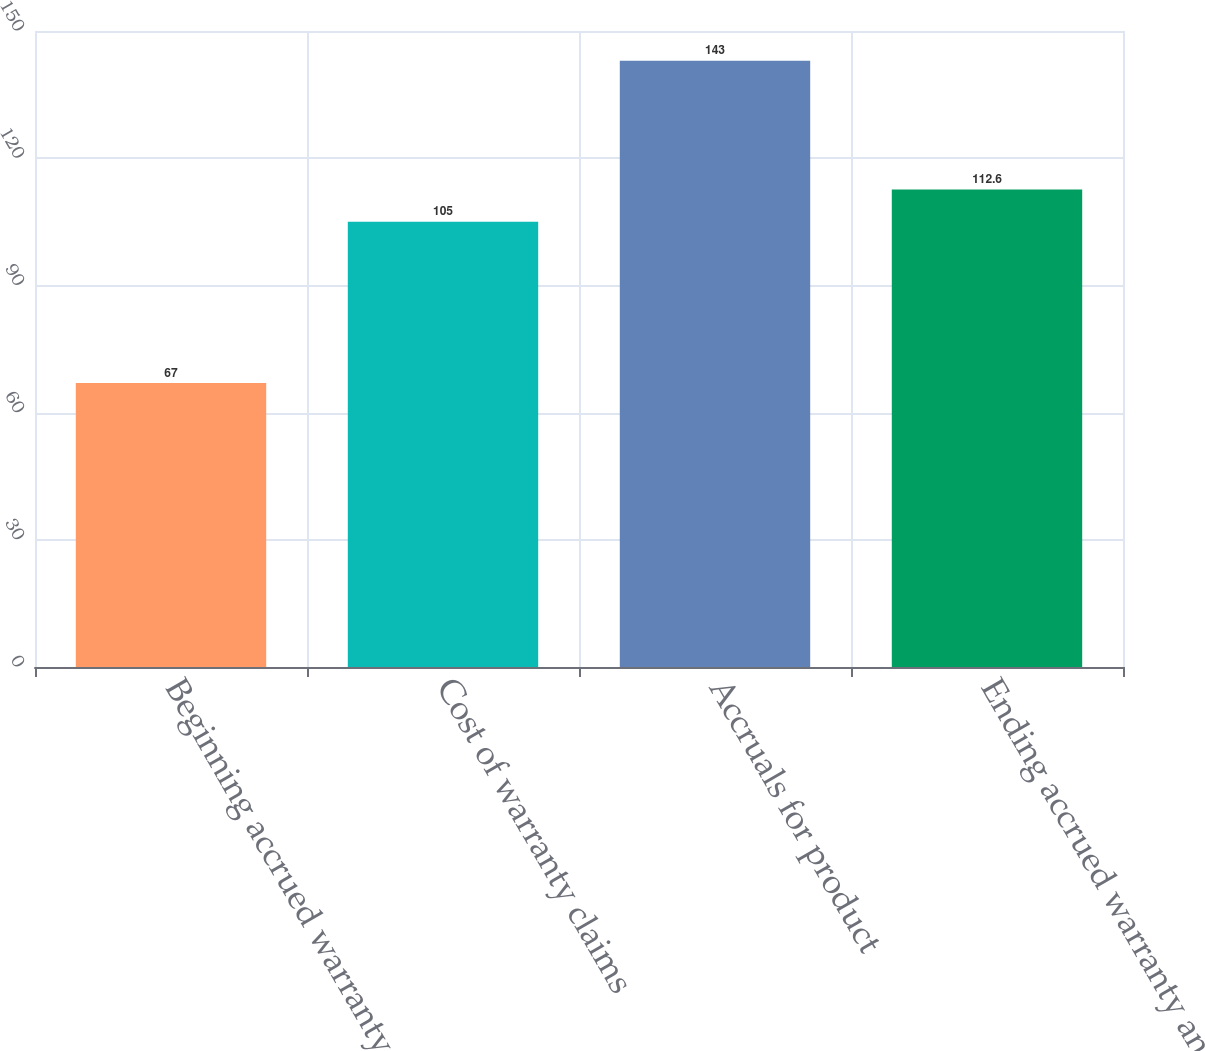Convert chart to OTSL. <chart><loc_0><loc_0><loc_500><loc_500><bar_chart><fcel>Beginning accrued warranty and<fcel>Cost of warranty claims<fcel>Accruals for product<fcel>Ending accrued warranty and<nl><fcel>67<fcel>105<fcel>143<fcel>112.6<nl></chart> 